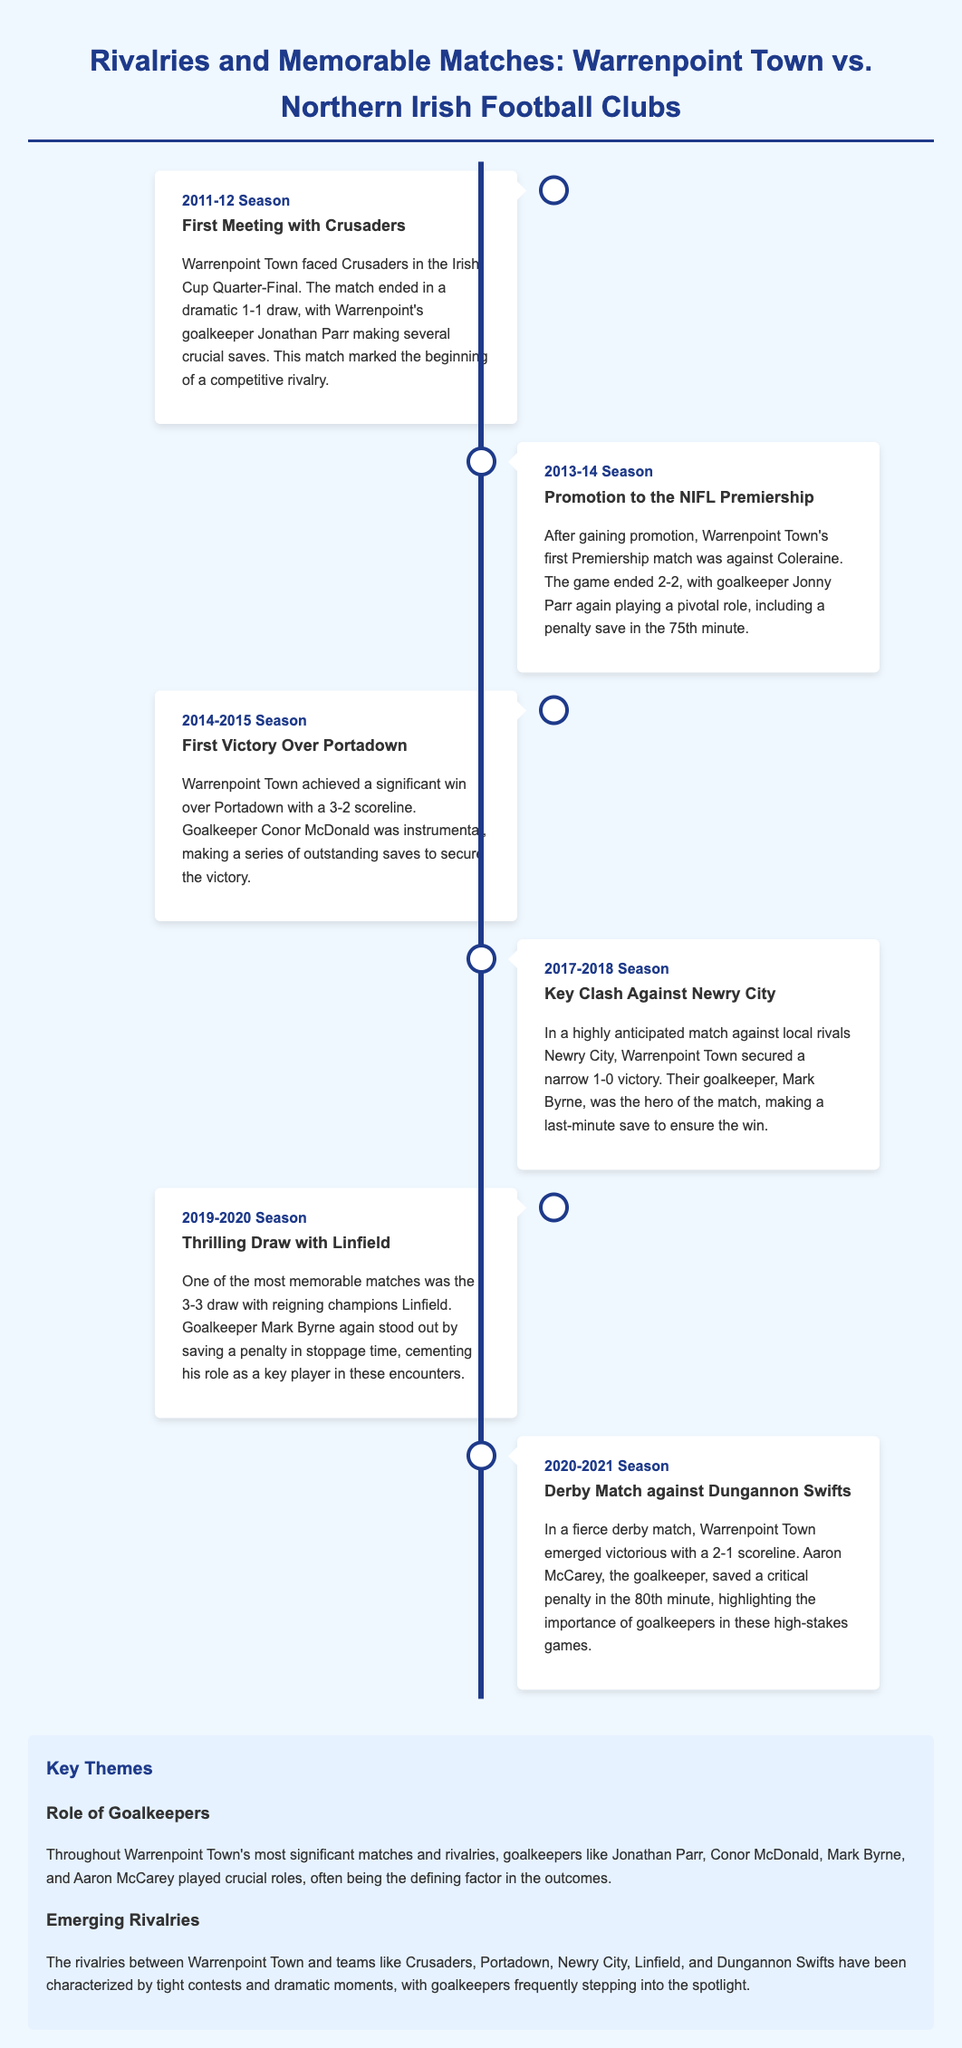what was the outcome of the first meeting with Crusaders? The first meeting with Crusaders ended in a dramatic 1-1 draw.
Answer: 1-1 draw which goalkeeper made crucial saves in the Irish Cup Quarter-Final? Jonathan Parr made several crucial saves in the Irish Cup Quarter-Final.
Answer: Jonathan Parr what was the score in the match against Portadown during the 2014-2015 season? Warrenpoint Town achieved a significant win over Portadown with a 3-2 scoreline.
Answer: 3-2 which season did Warrenpoint Town face Newry City? Warrenpoint Town secured a narrow victory against Newry City in the 2017-2018 season.
Answer: 2017-2018 Season what pivotal action did goalkeeper Jonny Parr take in the 2013-14 season? Jonny Parr played a pivotal role, including a penalty save in the 75th minute.
Answer: penalty save who was the goalkeeper during the thrilling draw with Linfield? Mark Byrne was the goalkeeper during the thrilling 3-3 draw with Linfield.
Answer: Mark Byrne which teams are mentioned as rivalries for Warrenpoint Town? The teams mentioned as rivalries include Crusaders, Portadown, Newry City, Linfield, and Dungannon Swifts.
Answer: Crusaders, Portadown, Newry City, Linfield, Dungannon Swifts what time period does the timeline cover? The timeline covers the span from the 2011-12 season to the 2020-21 season.
Answer: 2011-12 to 2020-21 what role do goalkeepers play according to the infographic? Goalkeepers played crucial roles and were often the defining factor in the outcomes.
Answer: crucial roles 